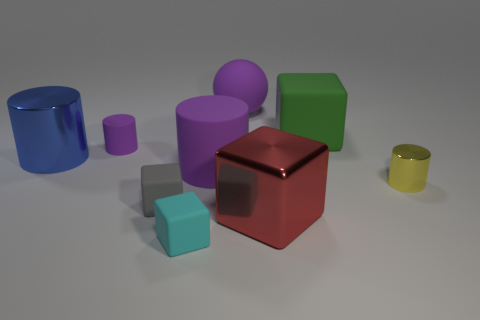What number of tiny things are the same color as the large matte cylinder?
Provide a succinct answer. 1. Is the color of the large metal cube the same as the shiny cylinder right of the green block?
Your answer should be very brief. No. There is a ball that is the same color as the tiny matte cylinder; what is it made of?
Keep it short and to the point. Rubber. Is there any other thing that has the same shape as the green thing?
Your answer should be very brief. Yes. The big metal object that is right of the big purple thing that is behind the large blue metal cylinder on the left side of the small cyan cube is what shape?
Provide a succinct answer. Cube. The green matte object has what shape?
Give a very brief answer. Cube. The tiny rubber cube to the left of the cyan matte object is what color?
Your answer should be compact. Gray. Do the metal cylinder to the right of the cyan cube and the gray rubber object have the same size?
Keep it short and to the point. Yes. There is a green thing that is the same shape as the red object; what is its size?
Offer a terse response. Large. Is there anything else that is the same size as the red block?
Offer a terse response. Yes. 